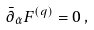Convert formula to latex. <formula><loc_0><loc_0><loc_500><loc_500>\bar { \partial } _ { \dot { \alpha } } F ^ { ( q ) } = 0 \, ,</formula> 